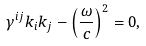<formula> <loc_0><loc_0><loc_500><loc_500>\gamma ^ { i j } k _ { i } k _ { j } - \left ( \frac { \omega } { c } \right ) ^ { 2 } = 0 ,</formula> 